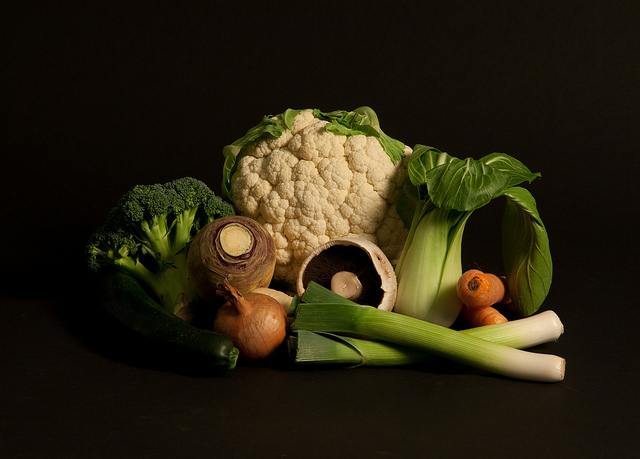How can these vegetables be used in a meal? The vegetables in the image can be used in a variety of meals. Broccoli and cauliflower are excellent when steamed or roasted as side dishes, or chopped into florets for a veggie stir-fry. The leek can be sliced and sautéed to add a mild oniony flavor to soups and pies. Onions are versatile and can be caramelized for a sweet addition to burgers or diced for flavor in salsas and salads. The Portobello mushroom is great for grilling or stuffing with cheese and herbs. 